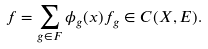<formula> <loc_0><loc_0><loc_500><loc_500>f = \sum _ { g \in F } \phi _ { g } ( x ) f _ { g } \in C ( X , E ) .</formula> 